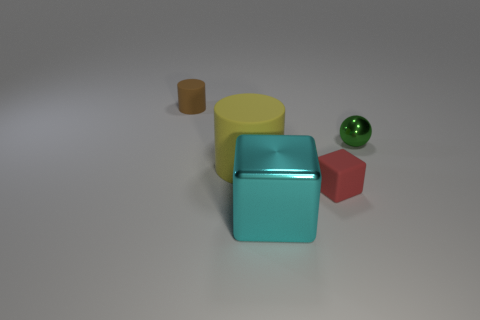Can you tell me what the green object behind the red block is made of? The green object behind the red block has a glossy surface and is likely made of glass or polished stone, given its reflective and smooth appearance. 